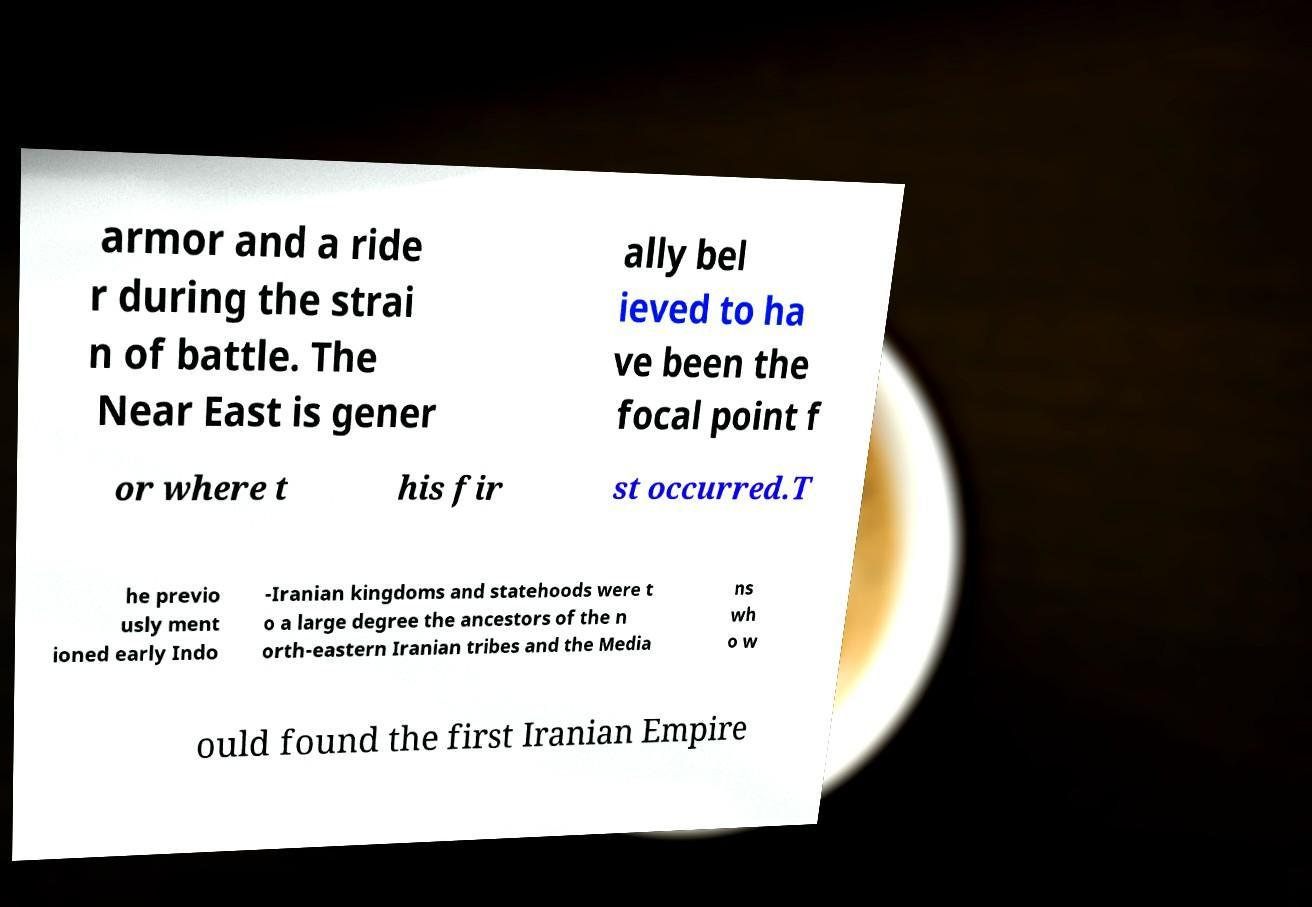Please identify and transcribe the text found in this image. armor and a ride r during the strai n of battle. The Near East is gener ally bel ieved to ha ve been the focal point f or where t his fir st occurred.T he previo usly ment ioned early Indo -Iranian kingdoms and statehoods were t o a large degree the ancestors of the n orth-eastern Iranian tribes and the Media ns wh o w ould found the first Iranian Empire 